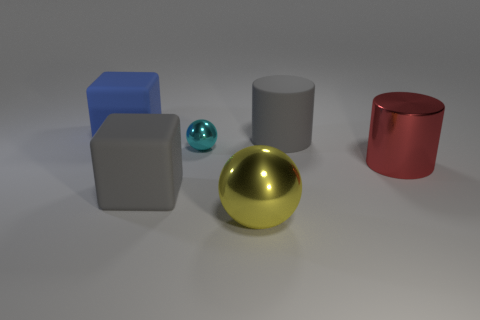What material is the big block that is the same color as the big rubber cylinder?
Make the answer very short. Rubber. How many other things are there of the same material as the cyan object?
Keep it short and to the point. 2. Are there the same number of cyan metal things that are behind the big blue rubber block and cyan shiny objects in front of the small object?
Keep it short and to the point. Yes. There is a big rubber thing behind the large gray thing that is behind the matte block that is in front of the big rubber cylinder; what color is it?
Offer a terse response. Blue. There is a big gray matte thing that is to the left of the gray cylinder; what is its shape?
Provide a succinct answer. Cube. There is a red object that is the same material as the small sphere; what shape is it?
Ensure brevity in your answer.  Cylinder. Is there anything else that has the same shape as the yellow metal thing?
Offer a very short reply. Yes. There is a yellow metal thing; how many red cylinders are behind it?
Offer a terse response. 1. Is the number of metallic cylinders that are behind the large red metallic cylinder the same as the number of small purple rubber blocks?
Provide a succinct answer. Yes. Does the large red cylinder have the same material as the tiny thing?
Make the answer very short. Yes. 